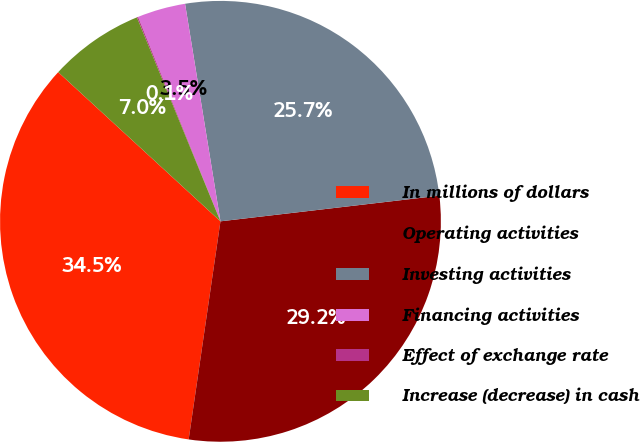Convert chart. <chart><loc_0><loc_0><loc_500><loc_500><pie_chart><fcel>In millions of dollars<fcel>Operating activities<fcel>Investing activities<fcel>Financing activities<fcel>Effect of exchange rate<fcel>Increase (decrease) in cash<nl><fcel>34.53%<fcel>29.16%<fcel>25.71%<fcel>3.53%<fcel>0.09%<fcel>6.98%<nl></chart> 